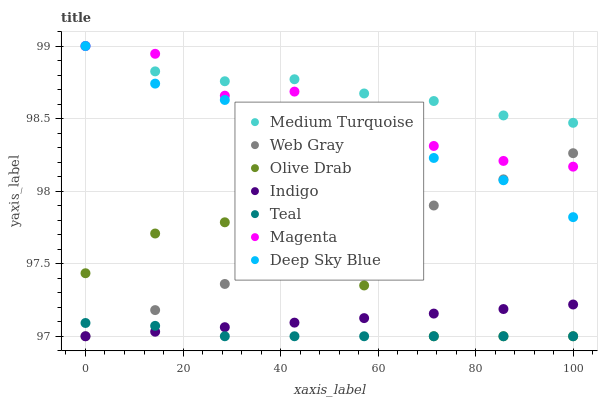Does Teal have the minimum area under the curve?
Answer yes or no. Yes. Does Medium Turquoise have the maximum area under the curve?
Answer yes or no. Yes. Does Indigo have the minimum area under the curve?
Answer yes or no. No. Does Indigo have the maximum area under the curve?
Answer yes or no. No. Is Indigo the smoothest?
Answer yes or no. Yes. Is Olive Drab the roughest?
Answer yes or no. Yes. Is Medium Turquoise the smoothest?
Answer yes or no. No. Is Medium Turquoise the roughest?
Answer yes or no. No. Does Web Gray have the lowest value?
Answer yes or no. Yes. Does Medium Turquoise have the lowest value?
Answer yes or no. No. Does Magenta have the highest value?
Answer yes or no. Yes. Does Indigo have the highest value?
Answer yes or no. No. Is Indigo less than Deep Sky Blue?
Answer yes or no. Yes. Is Medium Turquoise greater than Web Gray?
Answer yes or no. Yes. Does Teal intersect Web Gray?
Answer yes or no. Yes. Is Teal less than Web Gray?
Answer yes or no. No. Is Teal greater than Web Gray?
Answer yes or no. No. Does Indigo intersect Deep Sky Blue?
Answer yes or no. No. 